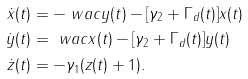Convert formula to latex. <formula><loc_0><loc_0><loc_500><loc_500>\dot { x } ( t ) & = - \ w a c y ( t ) - [ \gamma _ { 2 } + \Gamma _ { d } ( t ) ] x ( t ) \\ \dot { y } ( t ) & = \ w a c x ( t ) - [ \gamma _ { 2 } + \Gamma _ { d } ( t ) ] y ( t ) \\ \dot { z } ( t ) & = - \gamma _ { 1 } ( z ( t ) + 1 ) .</formula> 